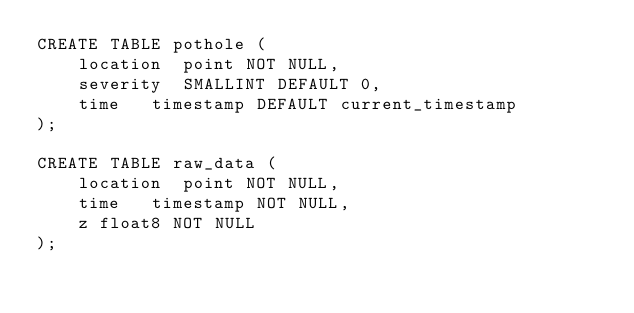<code> <loc_0><loc_0><loc_500><loc_500><_SQL_>CREATE TABLE pothole (
    location  point NOT NULL,
    severity  SMALLINT DEFAULT 0,
    time   timestamp DEFAULT current_timestamp
);

CREATE TABLE raw_data (
    location  point NOT NULL,
    time   timestamp NOT NULL,
    z float8 NOT NULL
);</code> 